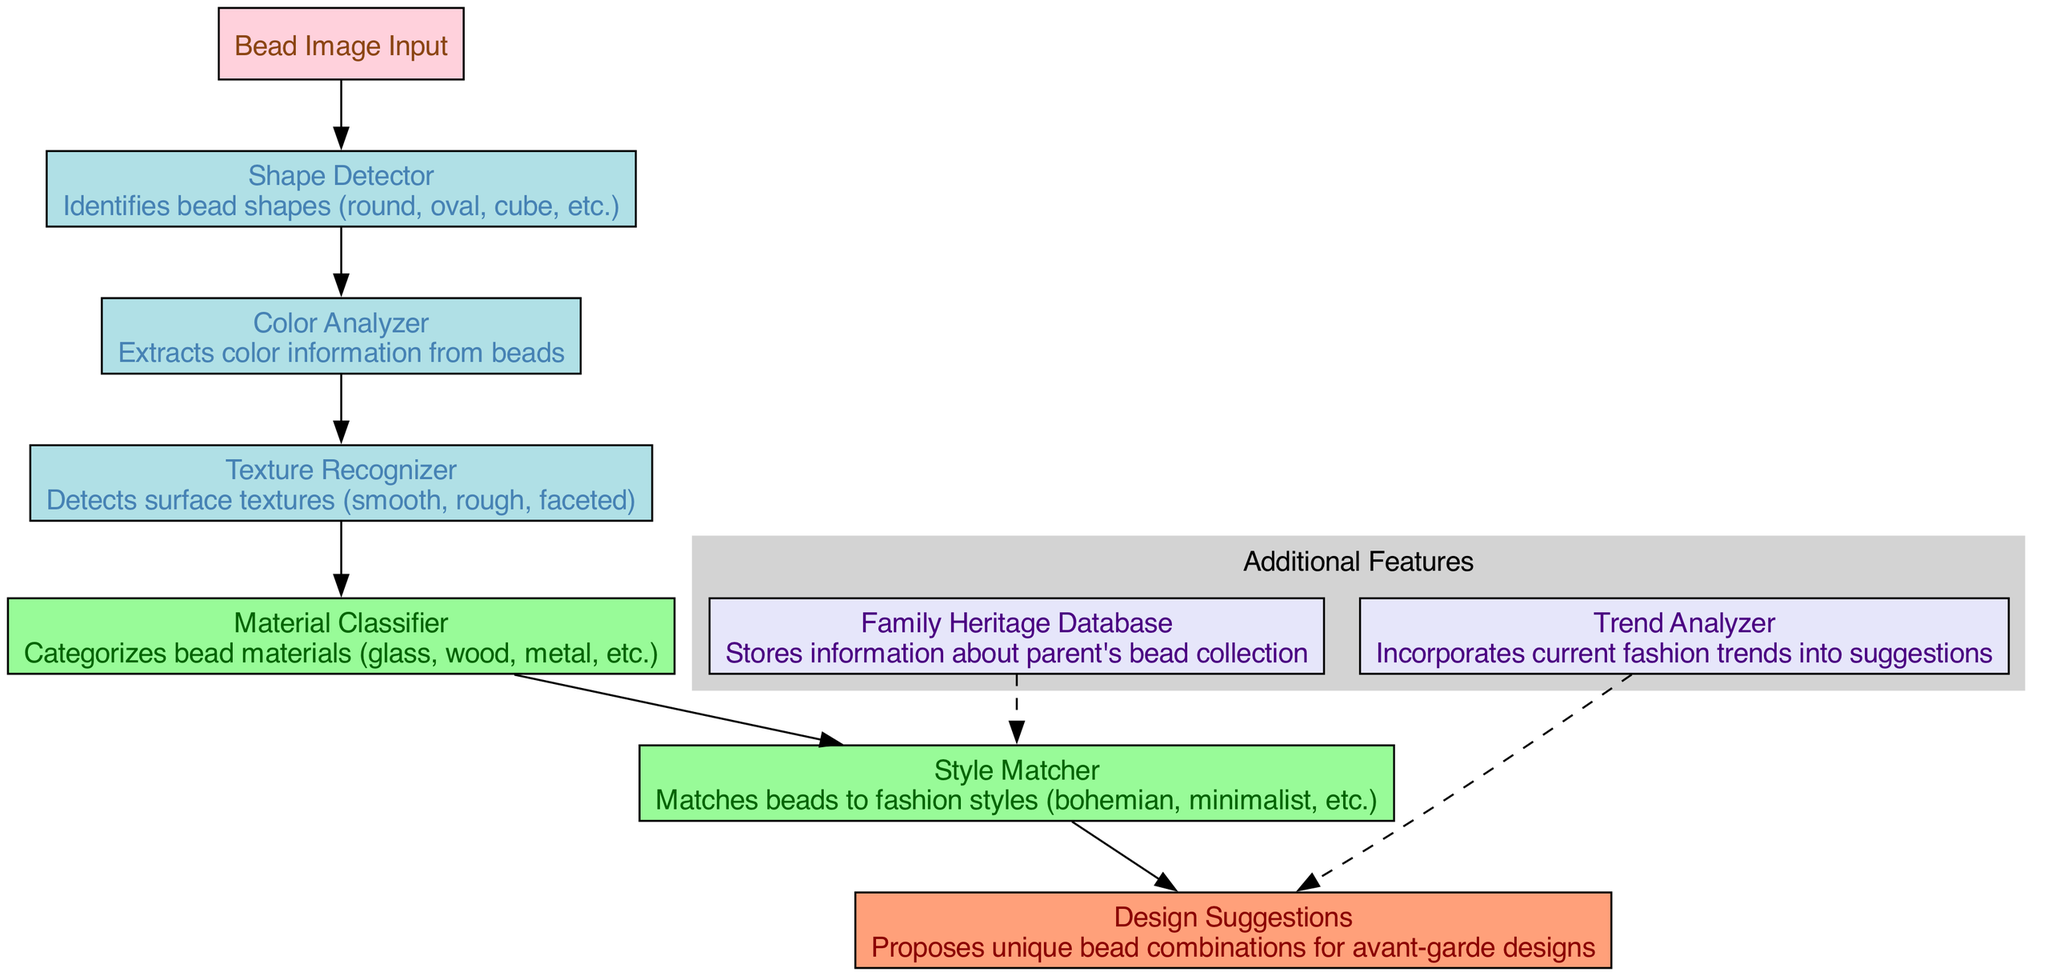What is the name of the input layer? The input layer is named "Bead Image Input", as indicated in the diagram where it is labeled.
Answer: Bead Image Input How many convolutional layers are there? There are three convolutional layers labeled as "Shape Detector", "Color Analyzer", and "Texture Recognizer". Each one is represented distinctly in the diagram.
Answer: 3 What is the role of the "Style Matcher"? The "Style Matcher" layer is responsible for matching beads to various fashion styles, as described in the layer's text within the diagram.
Answer: Matches beads to fashion styles What type of data does the "Family Heritage Database" feature store? The "Family Heritage Database" feature stores information about the parent's bead collection, as per its description within the diagram.
Answer: Parent's bead collection What connects the "Texture Recognizer" and the "Material Classifier"? The "Texture Recognizer" connects to the "Material Classifier" through a directed edge, indicating the flow of information from the convolutional layer to the fully connected layer.
Answer: Directed edge Which layers are used for extracting color information from beads? The layer labeled "Color Analyzer" is identified as the layer that extracts color information, being explicitly described in the diagram.
Answer: Color Analyzer Which feature is responsible for incorporating current fashion trends? The feature responsible for this task is the "Trend Analyzer", which is indicated clearly in the section of additional features within the diagram.
Answer: Trend Analyzer What is the output of the neural network architecture? The output layer is named "Design Suggestions", and it proposes unique bead combinations for avant-garde designs, as stated in its description in the diagram.
Answer: Design Suggestions What is the color of the fully connected layers in the diagram? The fully connected layers are colored in a light green shade, specifically indicated in the details of the diagram regarding node formatting.
Answer: Light green 